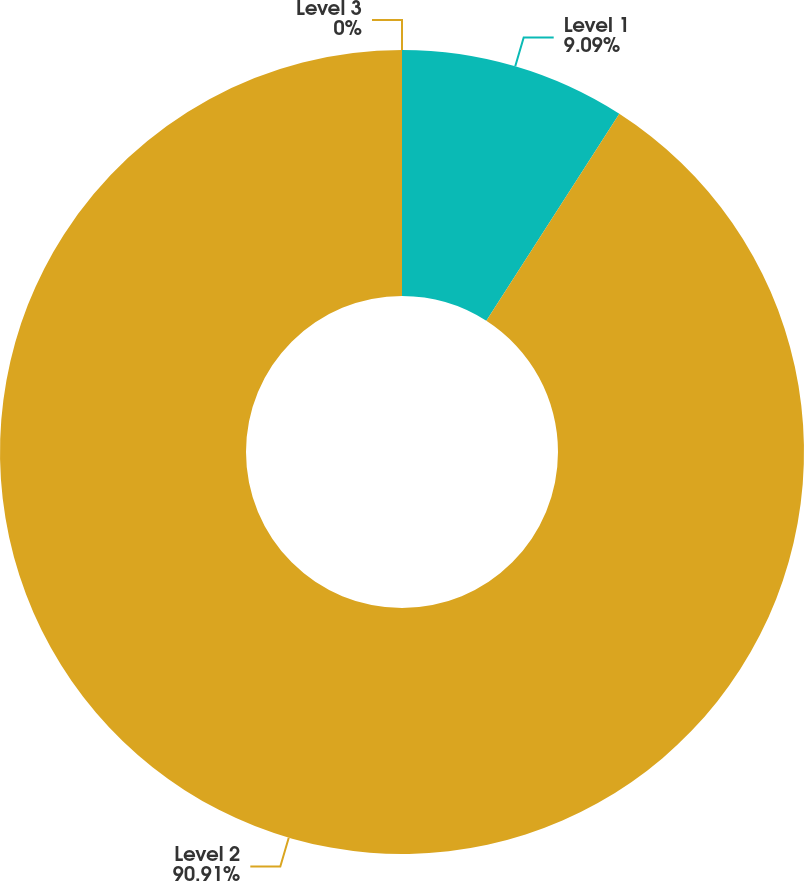Convert chart to OTSL. <chart><loc_0><loc_0><loc_500><loc_500><pie_chart><fcel>Level 1<fcel>Level 2<fcel>Level 3<nl><fcel>9.09%<fcel>90.91%<fcel>0.0%<nl></chart> 